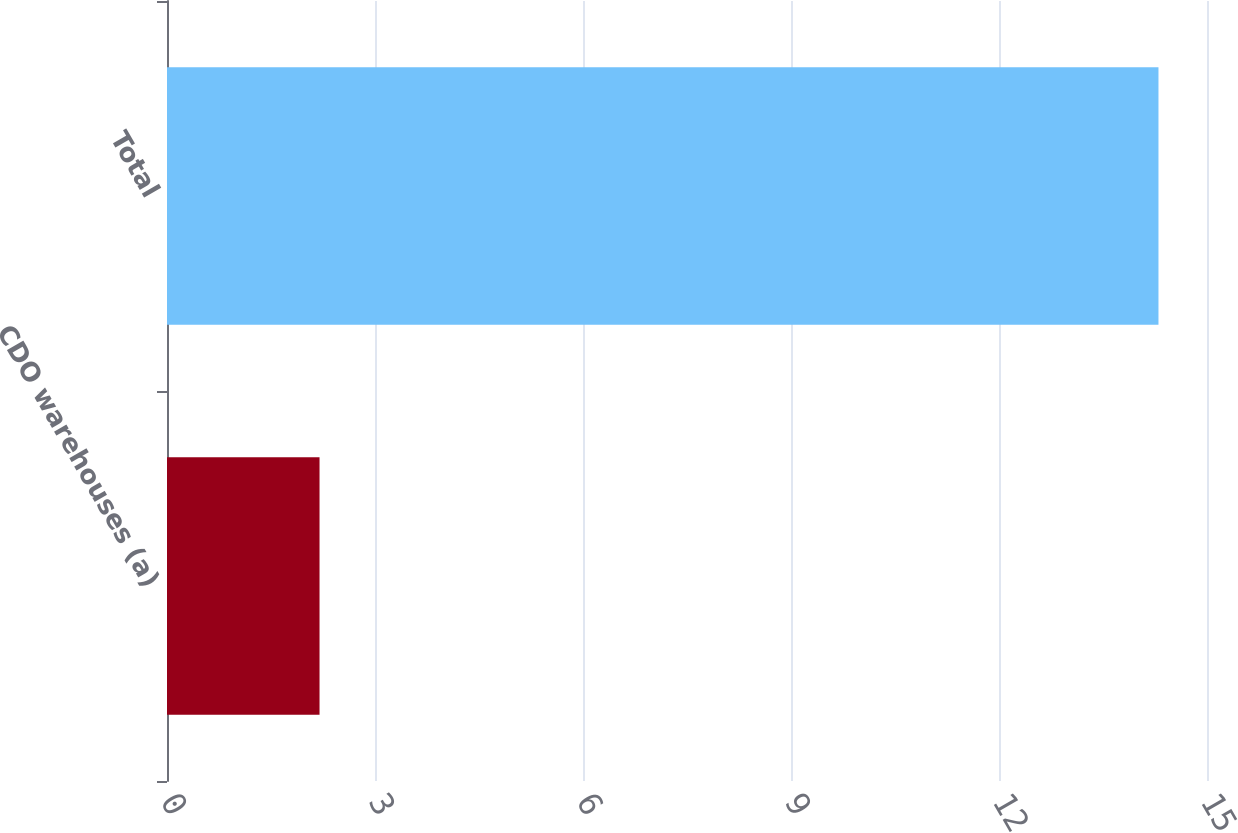Convert chart. <chart><loc_0><loc_0><loc_500><loc_500><bar_chart><fcel>CDO warehouses (a)<fcel>Total<nl><fcel>2.2<fcel>14.3<nl></chart> 